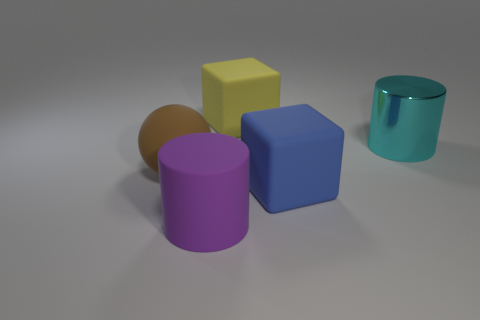Is there any other thing that is the same material as the big cyan cylinder?
Offer a terse response. No. The shiny thing has what color?
Your response must be concise. Cyan. Are there any other matte cylinders that have the same color as the large rubber cylinder?
Provide a short and direct response. No. Is the number of blue spheres less than the number of big cylinders?
Offer a very short reply. Yes. There is a object that is behind the purple thing and to the left of the yellow matte object; what is its size?
Keep it short and to the point. Large. There is a large yellow object; what number of purple cylinders are to the left of it?
Provide a short and direct response. 1. Are there more gray matte balls than big matte cylinders?
Your answer should be compact. No. There is a rubber object that is both left of the blue rubber object and in front of the big brown sphere; what shape is it?
Ensure brevity in your answer.  Cylinder. Is there a small green matte thing?
Provide a short and direct response. No. What material is the large blue object that is the same shape as the big yellow thing?
Your answer should be compact. Rubber. 